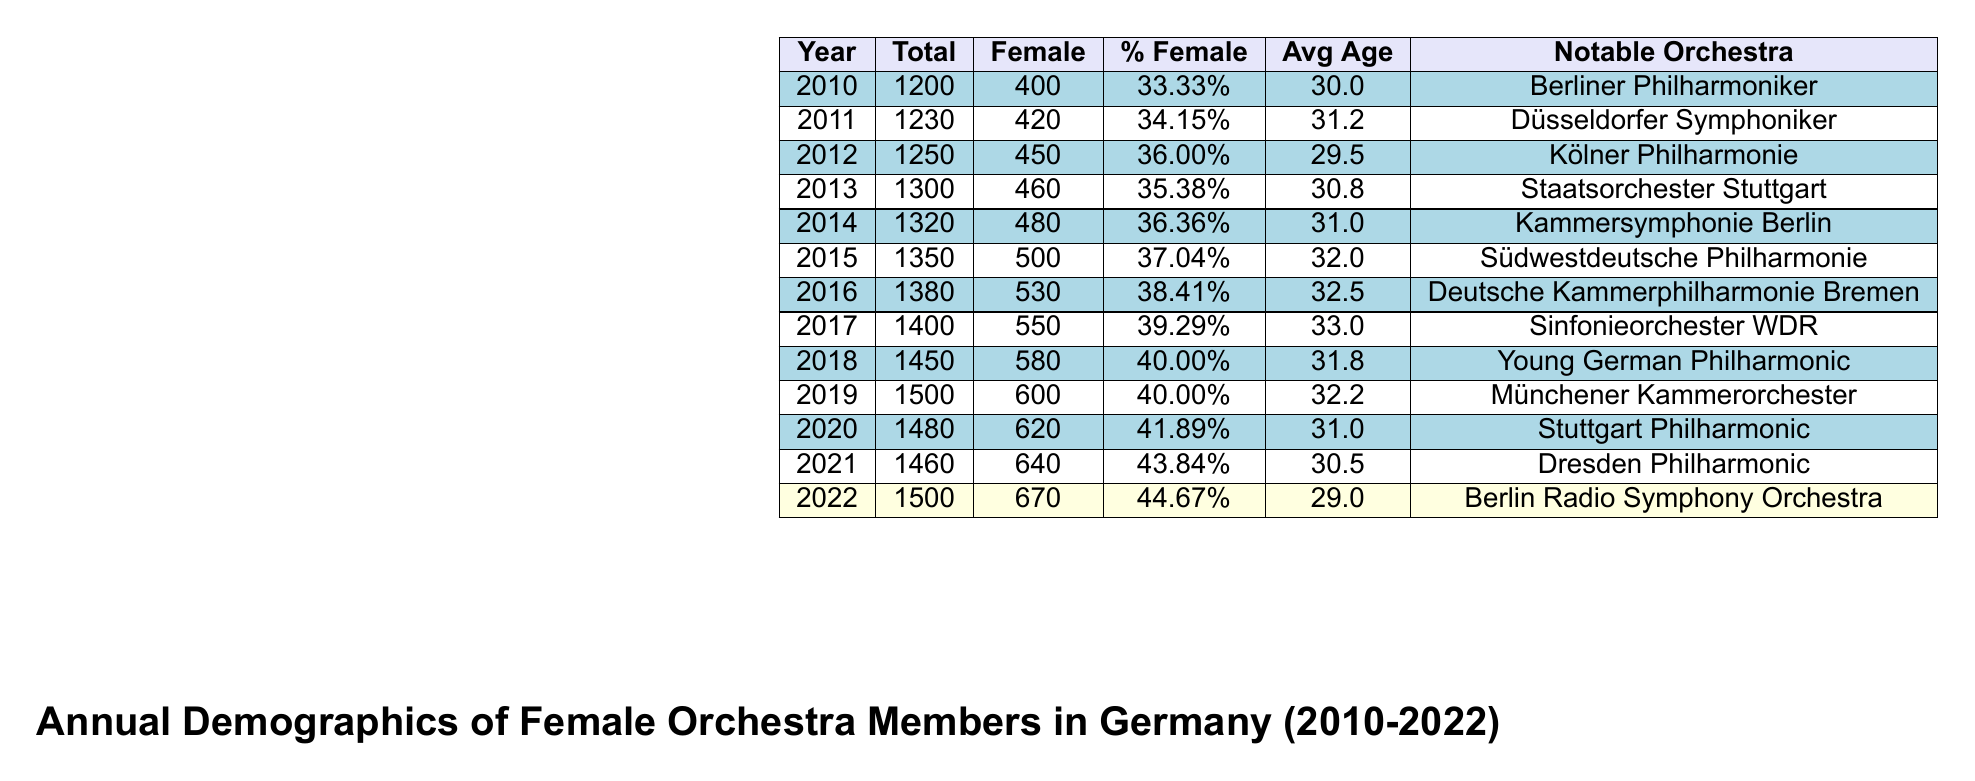What was the total number of female orchestra members in Germany in 2015? The table shows the total number of female orchestra members for each year. In the year 2015, the value listed under "Female" is 500.
Answer: 500 What percentage of female members was recorded in 2021? Looking at the data for 2021, the percentage of female members is given as 43.84%.
Answer: 43.84% Which year saw the highest average age among female orchestra members? The average ages for each year are listed in the table. The highest average age is 33.0 in 2017.
Answer: 33.0 In which year did the percentage of female orchestra members first exceed 40%? By examining the percentages from each year, it is evident that in 2018, the percentage of female members reached 40.00% for the first time.
Answer: 2018 How many more female orchestra members were there in 2022 compared to 2010? The number of female members in 2022 is 670 and in 2010 it was 400. The difference is calculated by subtracting 400 from 670, which gives 270.
Answer: 270 Is the average age of female orchestra members generally increasing or decreasing over this period? By reviewing the average ages from 2010 to 2022, we note that the average age started at 30.0 in 2010 and ended at 29.0 in 2022, indicating a decrease over the years.
Answer: Decreasing What was the total number of female members from 2010 to 2012 combined? Summing up the female members from 2010 (400), 2011 (420), and 2012 (450) gives: 400 + 420 + 450 = 1270.
Answer: 1270 Did the Berliner Philharmoniker appear as a notable orchestra in any year other than 2010? By looking at the column for notable orchestras, we see that Berliner Philharmoniker is only listed in 2010 and does not appear in any later years.
Answer: No Which year had the highest total number of orchestra members, and what was that total? The total members are highest in 2019, where it reached 1500.
Answer: 1500 